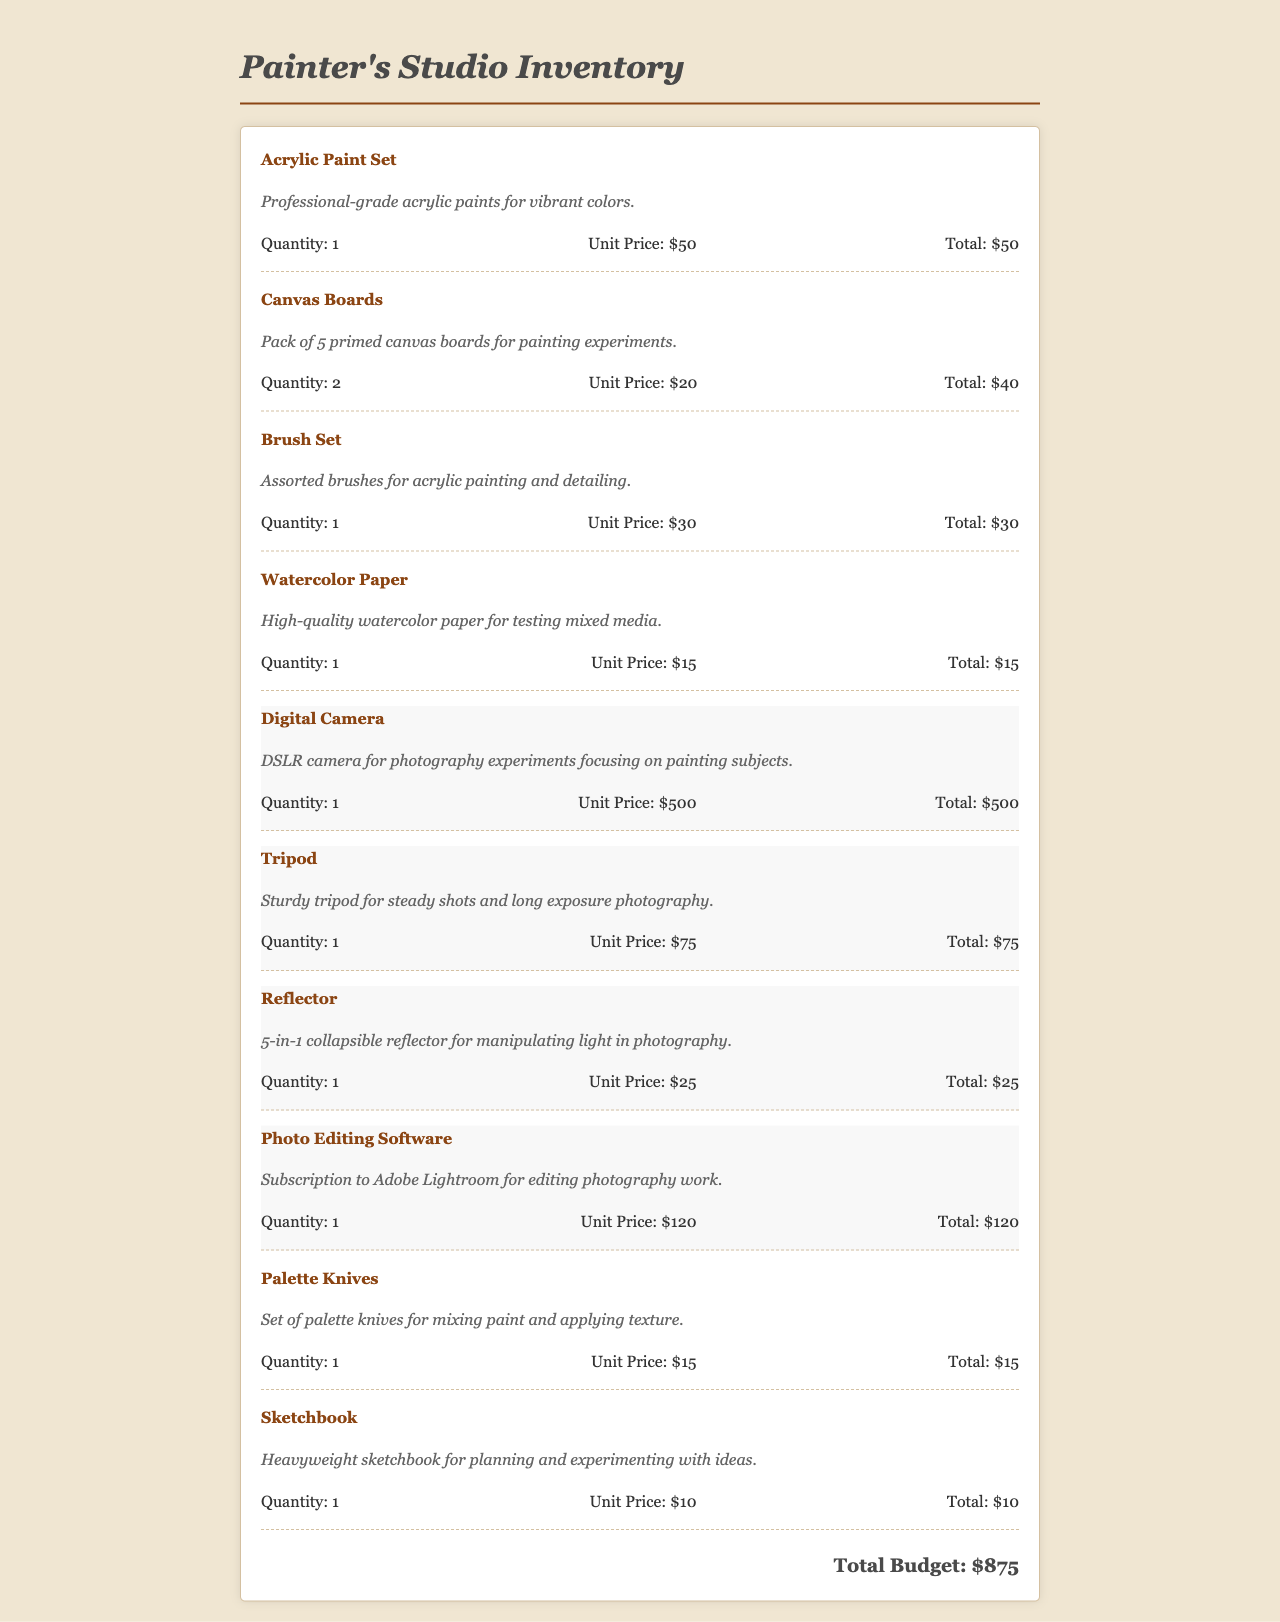what is the total budget? The total budget is the final amount calculated from all inventory items listed in the document.
Answer: $875 how many acrylic paint sets are listed? The document mentions a quantity of 1 for the acrylic paint set.
Answer: 1 what is the unit price of the digital camera? The unit price for the digital camera is a specific amount given in the item details.
Answer: $500 how many photography-related items are included in the inventory? The document contains a total of 4 items that are categorized as photography-related.
Answer: 4 which software subscription is mentioned in the inventory? The inventory lists a specific software subscription for photo editing along with its details.
Answer: Adobe Lightroom what is the total price of the canvas boards? The total price can be calculated by multiplying the quantity and unit price for the canvas boards listed in the inventory.
Answer: $40 how many colors are in the acrylic paint set? The inventory describes the acrylic paint set as a professional-grade set but does not specify the number of colors.
Answer: Not specified what is the quantity of tripods listed? The document directly states the number of tripods included in the inventory entry.
Answer: 1 what type of paper is included in the inventory? The inventory specifies a certain type of paper that is suited for particular artistic techniques.
Answer: Watercolor Paper 